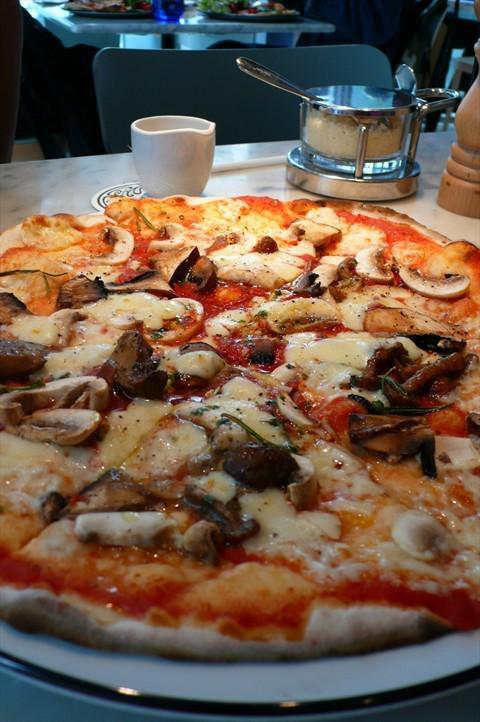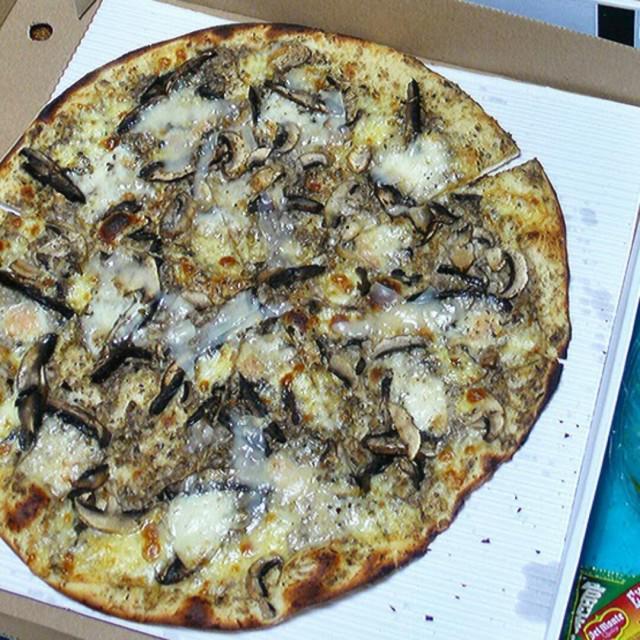The first image is the image on the left, the second image is the image on the right. Evaluate the accuracy of this statement regarding the images: "Two round baked pizzas are on plates, one of them topped with stemmed mushroom pieces.". Is it true? Answer yes or no. No. The first image is the image on the left, the second image is the image on the right. Given the left and right images, does the statement "In at least one image there is a pizza on a white plate with silver edging in front of a white tea cup." hold true? Answer yes or no. Yes. 